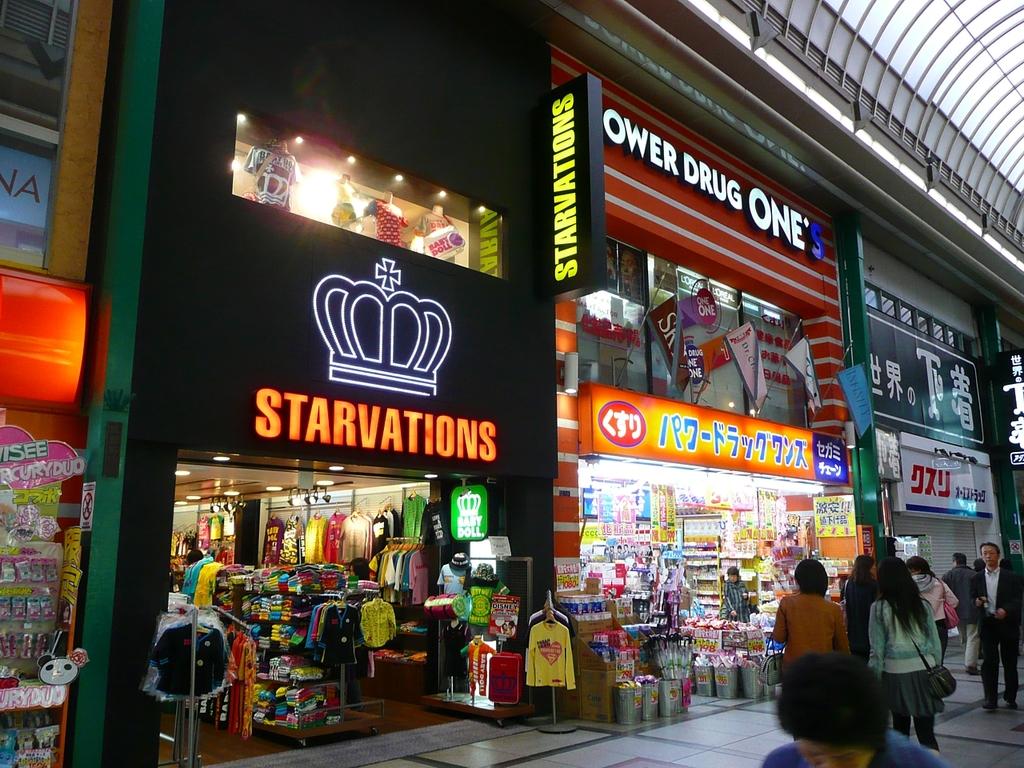What store is on top right?
Provide a succinct answer. Power drug one's. 